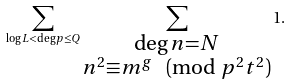<formula> <loc_0><loc_0><loc_500><loc_500>\sum _ { \log L < \deg p \leq Q } \sum _ { \substack { \deg n = N \\ n ^ { 2 } \equiv m ^ { g } \pmod { p ^ { 2 } t ^ { 2 } } } } 1 .</formula> 